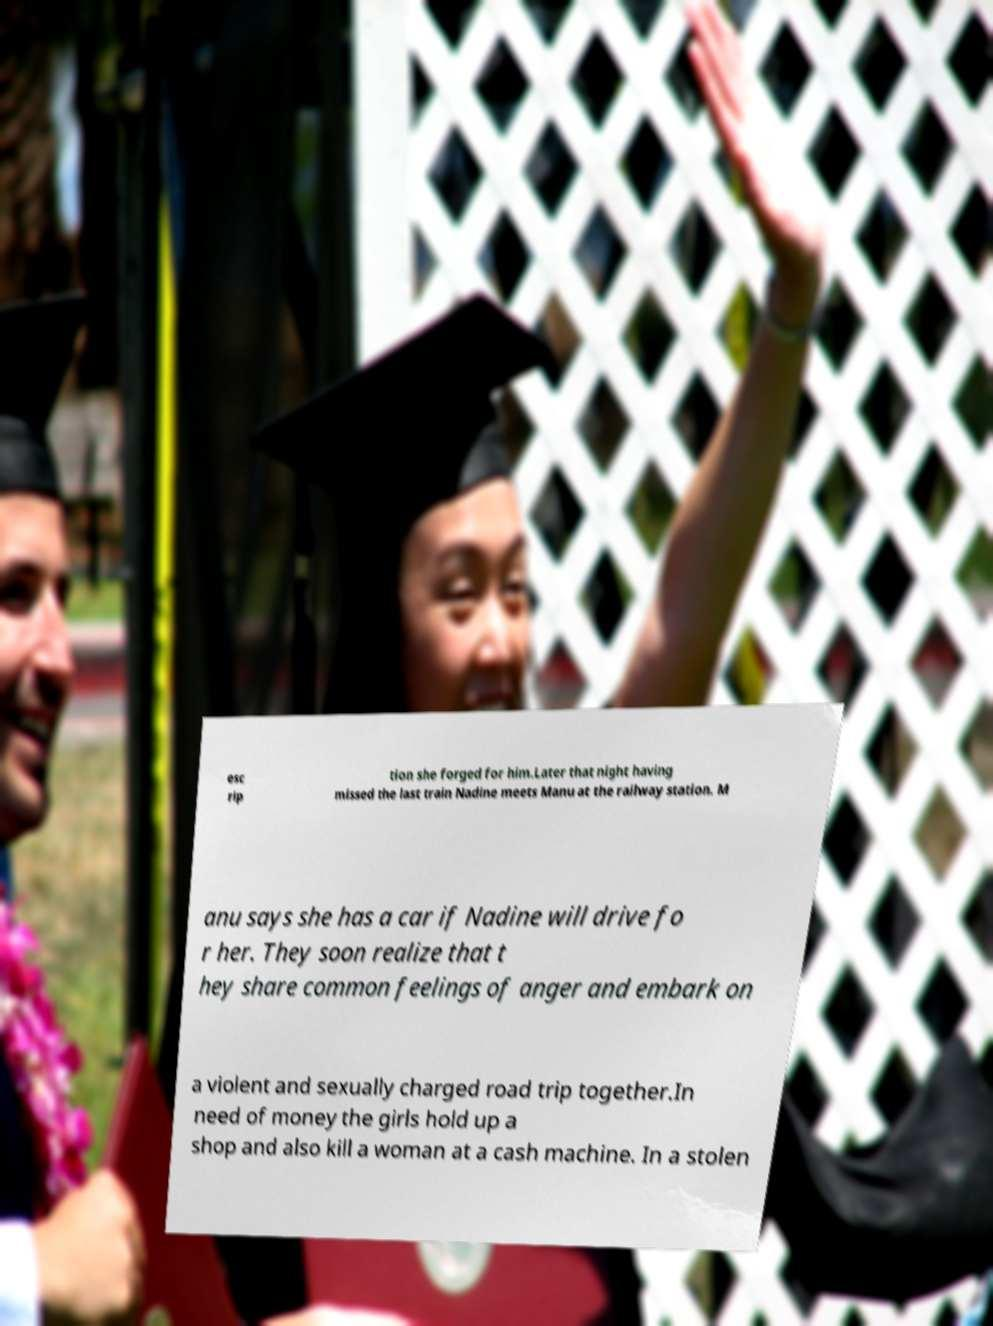For documentation purposes, I need the text within this image transcribed. Could you provide that? esc rip tion she forged for him.Later that night having missed the last train Nadine meets Manu at the railway station. M anu says she has a car if Nadine will drive fo r her. They soon realize that t hey share common feelings of anger and embark on a violent and sexually charged road trip together.In need of money the girls hold up a shop and also kill a woman at a cash machine. In a stolen 